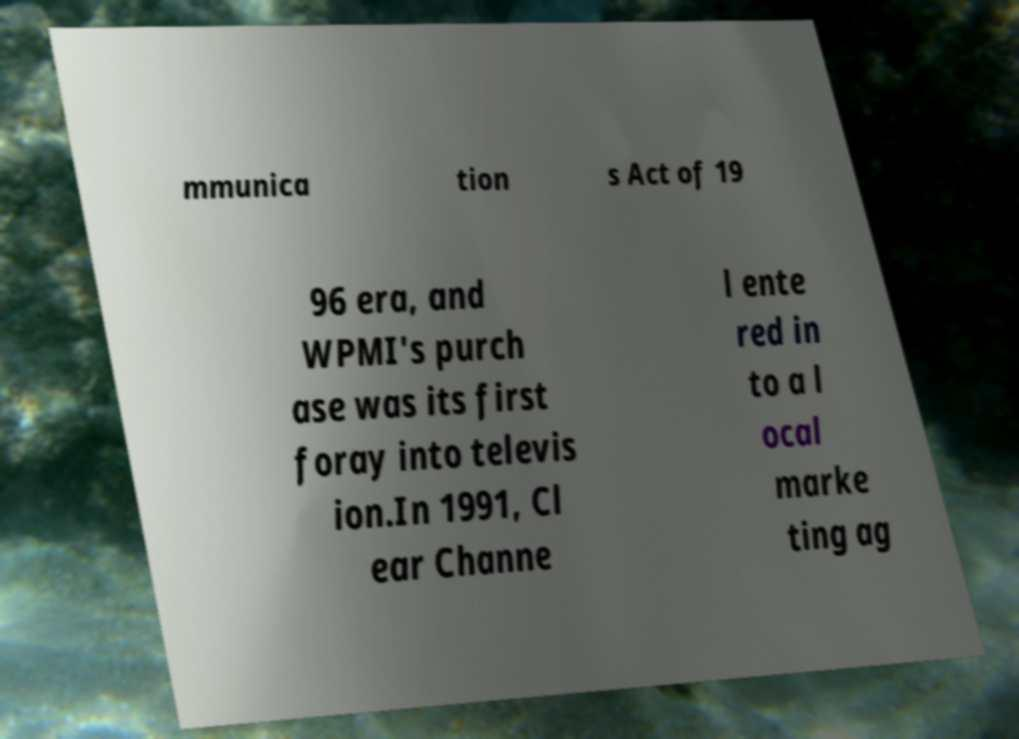Can you read and provide the text displayed in the image?This photo seems to have some interesting text. Can you extract and type it out for me? mmunica tion s Act of 19 96 era, and WPMI's purch ase was its first foray into televis ion.In 1991, Cl ear Channe l ente red in to a l ocal marke ting ag 